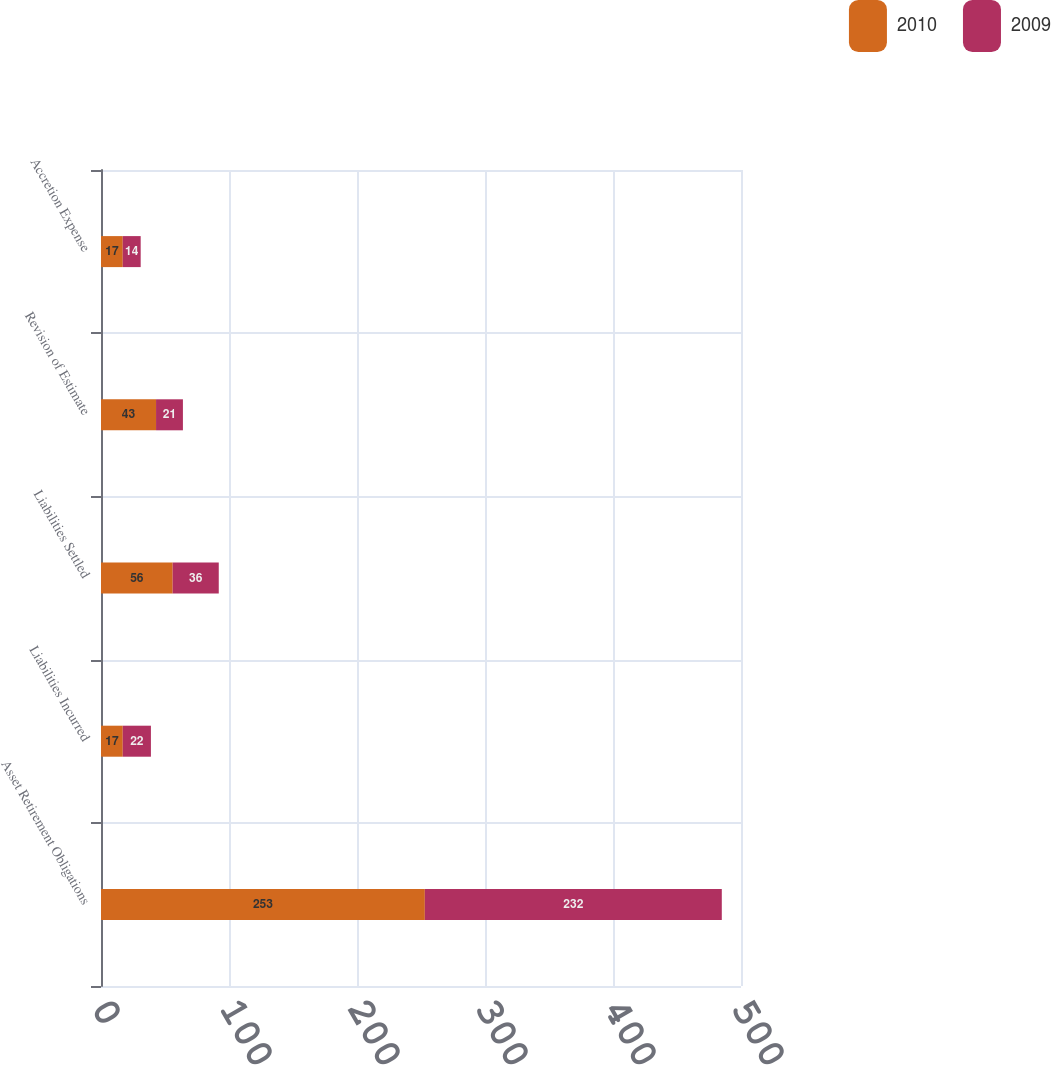Convert chart to OTSL. <chart><loc_0><loc_0><loc_500><loc_500><stacked_bar_chart><ecel><fcel>Asset Retirement Obligations<fcel>Liabilities Incurred<fcel>Liabilities Settled<fcel>Revision of Estimate<fcel>Accretion Expense<nl><fcel>2010<fcel>253<fcel>17<fcel>56<fcel>43<fcel>17<nl><fcel>2009<fcel>232<fcel>22<fcel>36<fcel>21<fcel>14<nl></chart> 